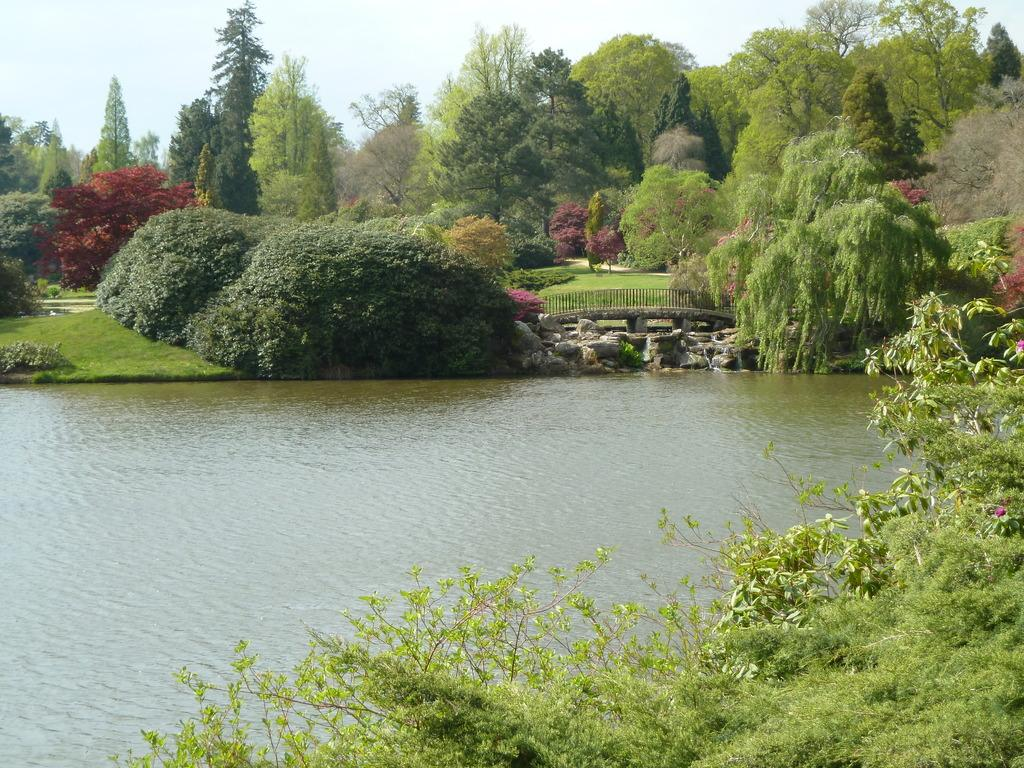What is the primary element visible in the image? There is water in the image. What types of vegetation can be seen in the image? There are plants and trees in the image. What type of structure is present in the image? There is a bridge in the image. What type of natural formation can be seen in the image? There are rocks in the image. What type of religion is practiced on the bridge in the image? There is no indication of any religious practice on the bridge in the image. How many crates are visible in the image? There are no crates present in the image. 